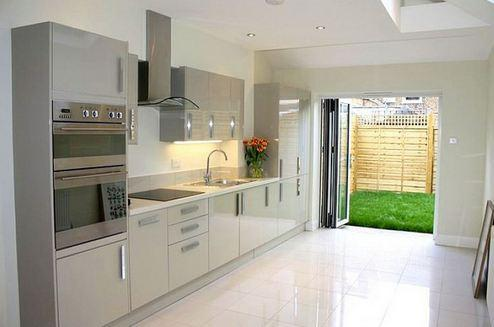Question: how many sinks are pictured?
Choices:
A. Zero.
B. Two.
C. One.
D. Three.
Answer with the letter. Answer: C Question: what color is the fence?
Choices:
A. Yellow.
B. Orange.
C. Light brown.
D. Red.
Answer with the letter. Answer: C Question: when is the photo taken?
Choices:
A. Night.
B. During the day.
C. Sunset.
D. Mother's Day.
Answer with the letter. Answer: B Question: what type of floor is shown?
Choices:
A. Tile.
B. Brick.
C. Carpeting.
D. Stone.
Answer with the letter. Answer: A 